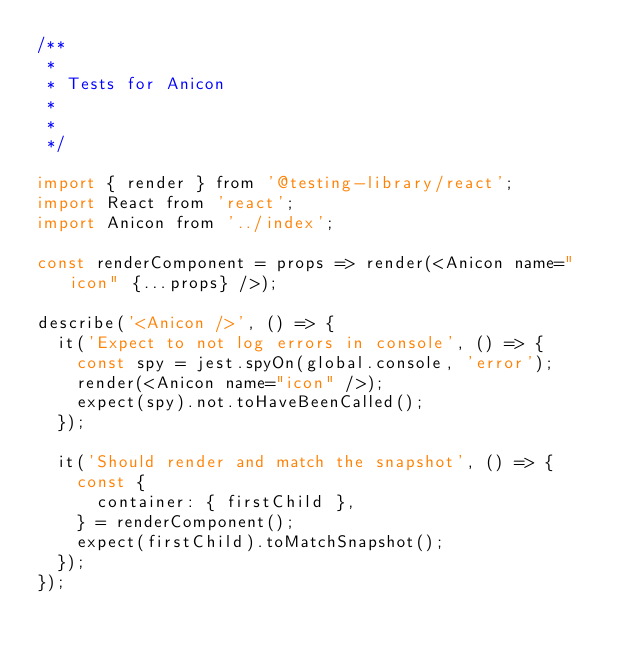Convert code to text. <code><loc_0><loc_0><loc_500><loc_500><_JavaScript_>/**
 *
 * Tests for Anicon
 *
 *
 */

import { render } from '@testing-library/react';
import React from 'react';
import Anicon from '../index';

const renderComponent = props => render(<Anicon name="icon" {...props} />);

describe('<Anicon />', () => {
  it('Expect to not log errors in console', () => {
    const spy = jest.spyOn(global.console, 'error');
    render(<Anicon name="icon" />);
    expect(spy).not.toHaveBeenCalled();
  });

  it('Should render and match the snapshot', () => {
    const {
      container: { firstChild },
    } = renderComponent();
    expect(firstChild).toMatchSnapshot();
  });
});
</code> 